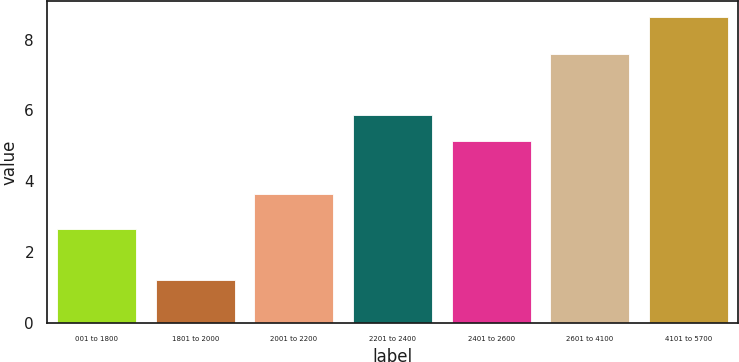Convert chart. <chart><loc_0><loc_0><loc_500><loc_500><bar_chart><fcel>001 to 1800<fcel>1801 to 2000<fcel>2001 to 2200<fcel>2201 to 2400<fcel>2401 to 2600<fcel>2601 to 4100<fcel>4101 to 5700<nl><fcel>2.64<fcel>1.22<fcel>3.64<fcel>5.87<fcel>5.13<fcel>7.6<fcel>8.65<nl></chart> 